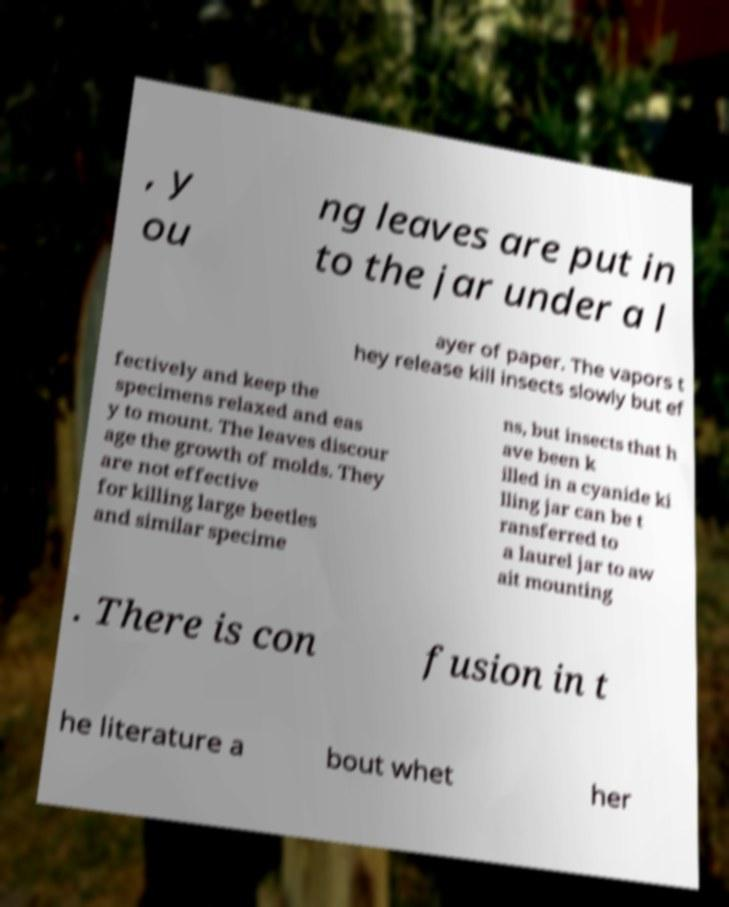There's text embedded in this image that I need extracted. Can you transcribe it verbatim? , y ou ng leaves are put in to the jar under a l ayer of paper. The vapors t hey release kill insects slowly but ef fectively and keep the specimens relaxed and eas y to mount. The leaves discour age the growth of molds. They are not effective for killing large beetles and similar specime ns, but insects that h ave been k illed in a cyanide ki lling jar can be t ransferred to a laurel jar to aw ait mounting . There is con fusion in t he literature a bout whet her 